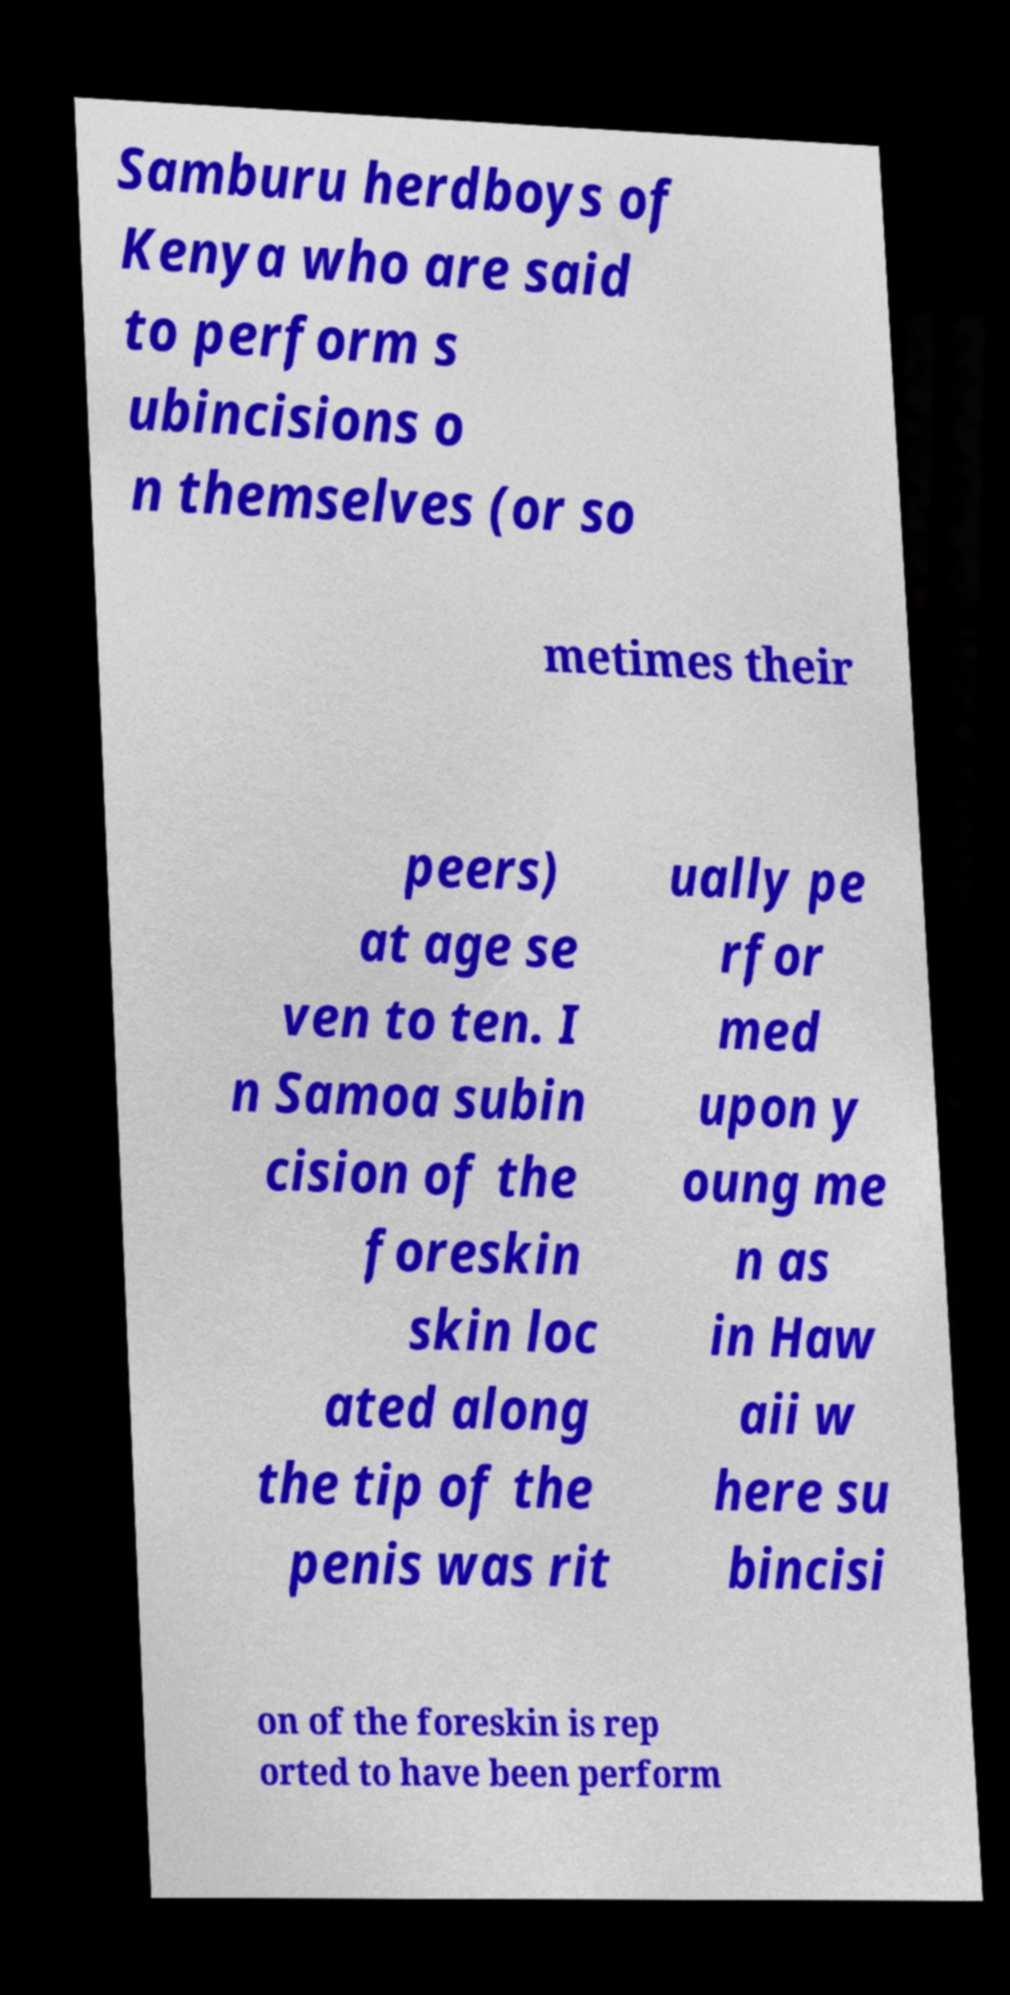Could you assist in decoding the text presented in this image and type it out clearly? Samburu herdboys of Kenya who are said to perform s ubincisions o n themselves (or so metimes their peers) at age se ven to ten. I n Samoa subin cision of the foreskin skin loc ated along the tip of the penis was rit ually pe rfor med upon y oung me n as in Haw aii w here su bincisi on of the foreskin is rep orted to have been perform 